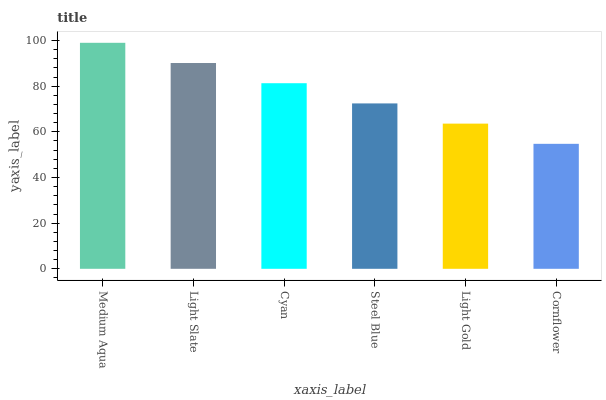Is Cornflower the minimum?
Answer yes or no. Yes. Is Medium Aqua the maximum?
Answer yes or no. Yes. Is Light Slate the minimum?
Answer yes or no. No. Is Light Slate the maximum?
Answer yes or no. No. Is Medium Aqua greater than Light Slate?
Answer yes or no. Yes. Is Light Slate less than Medium Aqua?
Answer yes or no. Yes. Is Light Slate greater than Medium Aqua?
Answer yes or no. No. Is Medium Aqua less than Light Slate?
Answer yes or no. No. Is Cyan the high median?
Answer yes or no. Yes. Is Steel Blue the low median?
Answer yes or no. Yes. Is Steel Blue the high median?
Answer yes or no. No. Is Light Slate the low median?
Answer yes or no. No. 